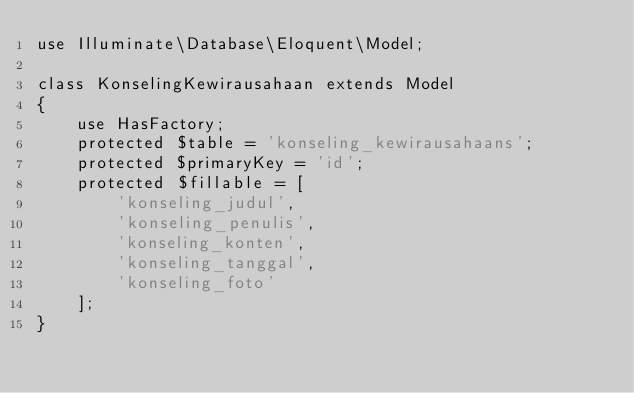<code> <loc_0><loc_0><loc_500><loc_500><_PHP_>use Illuminate\Database\Eloquent\Model;

class KonselingKewirausahaan extends Model
{
    use HasFactory;
    protected $table = 'konseling_kewirausahaans';
    protected $primaryKey = 'id';
    protected $fillable = [
        'konseling_judul',
        'konseling_penulis',
        'konseling_konten',
        'konseling_tanggal',
        'konseling_foto'
    ];
}
</code> 